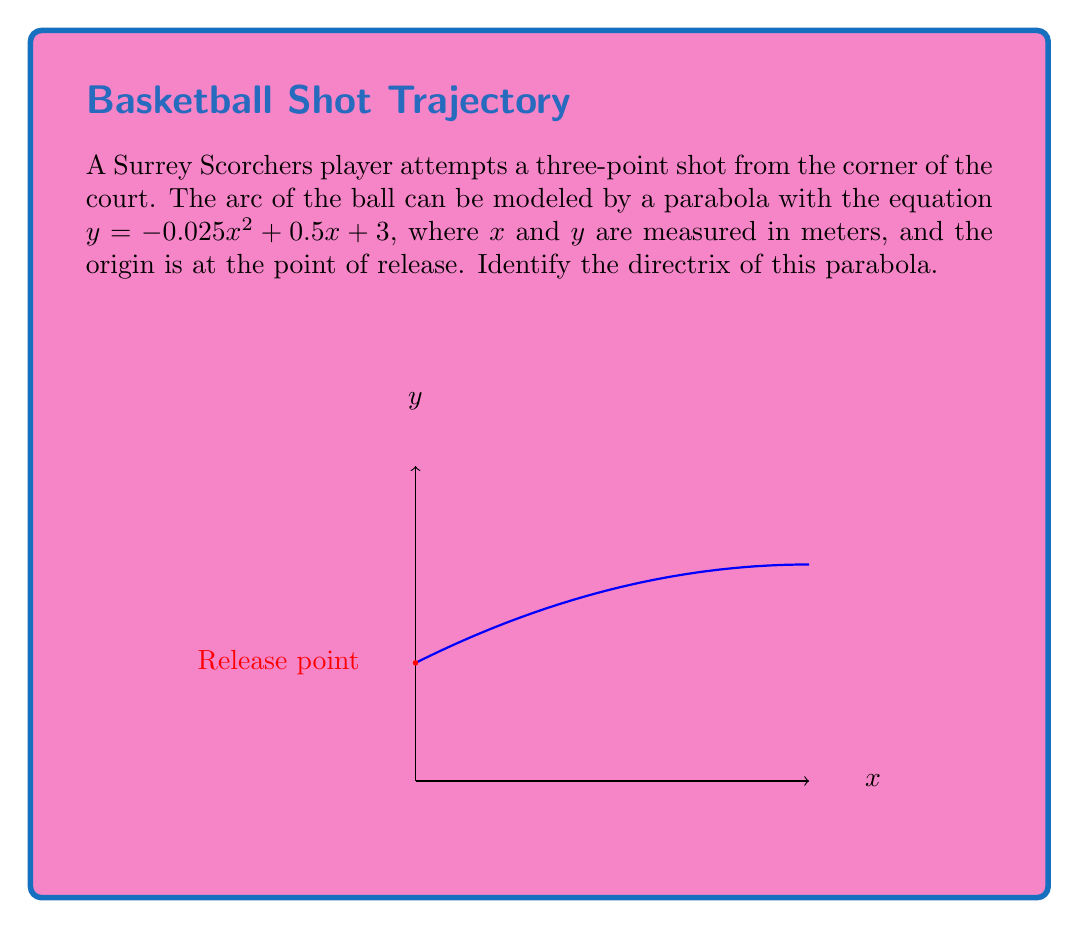What is the answer to this math problem? Let's approach this step-by-step:

1) The general form of a parabola is $y = ax^2 + bx + c$. In this case:
   $a = -0.025$, $b = 0.5$, and $c = 3$

2) For a parabola in the form $y = ax^2 + bx + c$, the vertex form is:
   $y = a(x-h)^2 + k$, where $(h,k)$ is the vertex

3) To find $h$: $h = -\frac{b}{2a} = -\frac{0.5}{2(-0.025)} = 10$

4) To find $k$, substitute $x=h$ into the original equation:
   $k = -0.025(10)^2 + 0.5(10) + 3 = 8$

5) So the vertex is $(10, 8)$

6) For a parabola with equation $y = a(x-h)^2 + k$, the focal length $p$ is given by:
   $p = \frac{1}{4|a|} = \frac{1}{4|-0.025|} = 10$

7) The directrix of a parabola is a horizontal line that is as far below the vertex as the focus is above it.

8) The distance from the vertex to the directrix is $p = 10$

9) Since the vertex is at $y = 8$, the directrix is at $y = 8 - 10 = -2$

Therefore, the equation of the directrix is $y = -2$.
Answer: $y = -2$ 